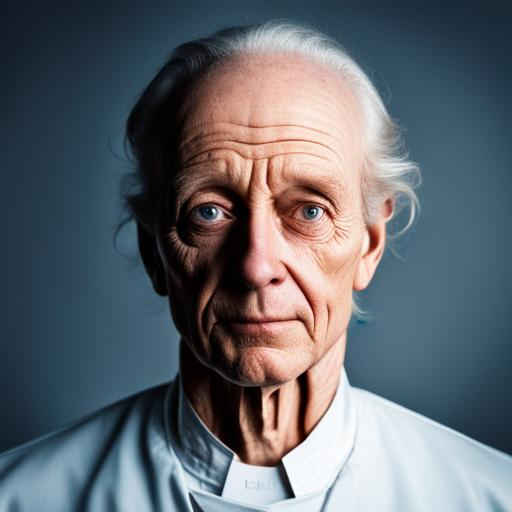Does the image have noise?
 No 